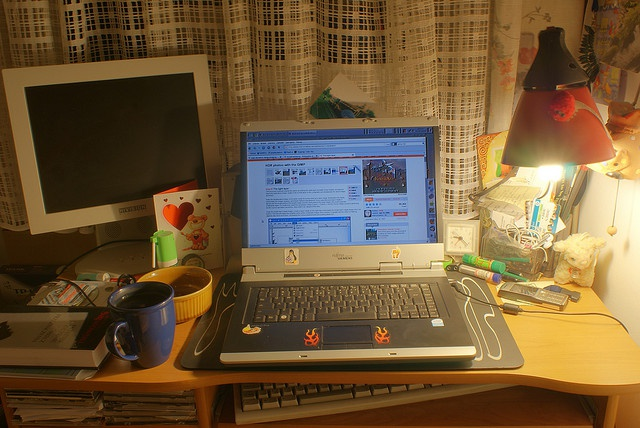Describe the objects in this image and their specific colors. I can see laptop in maroon, gray, darkgray, tan, and black tones, tv in maroon, black, and olive tones, keyboard in maroon, gray, black, and olive tones, keyboard in maroon, black, and brown tones, and cup in maroon, black, and gray tones in this image. 